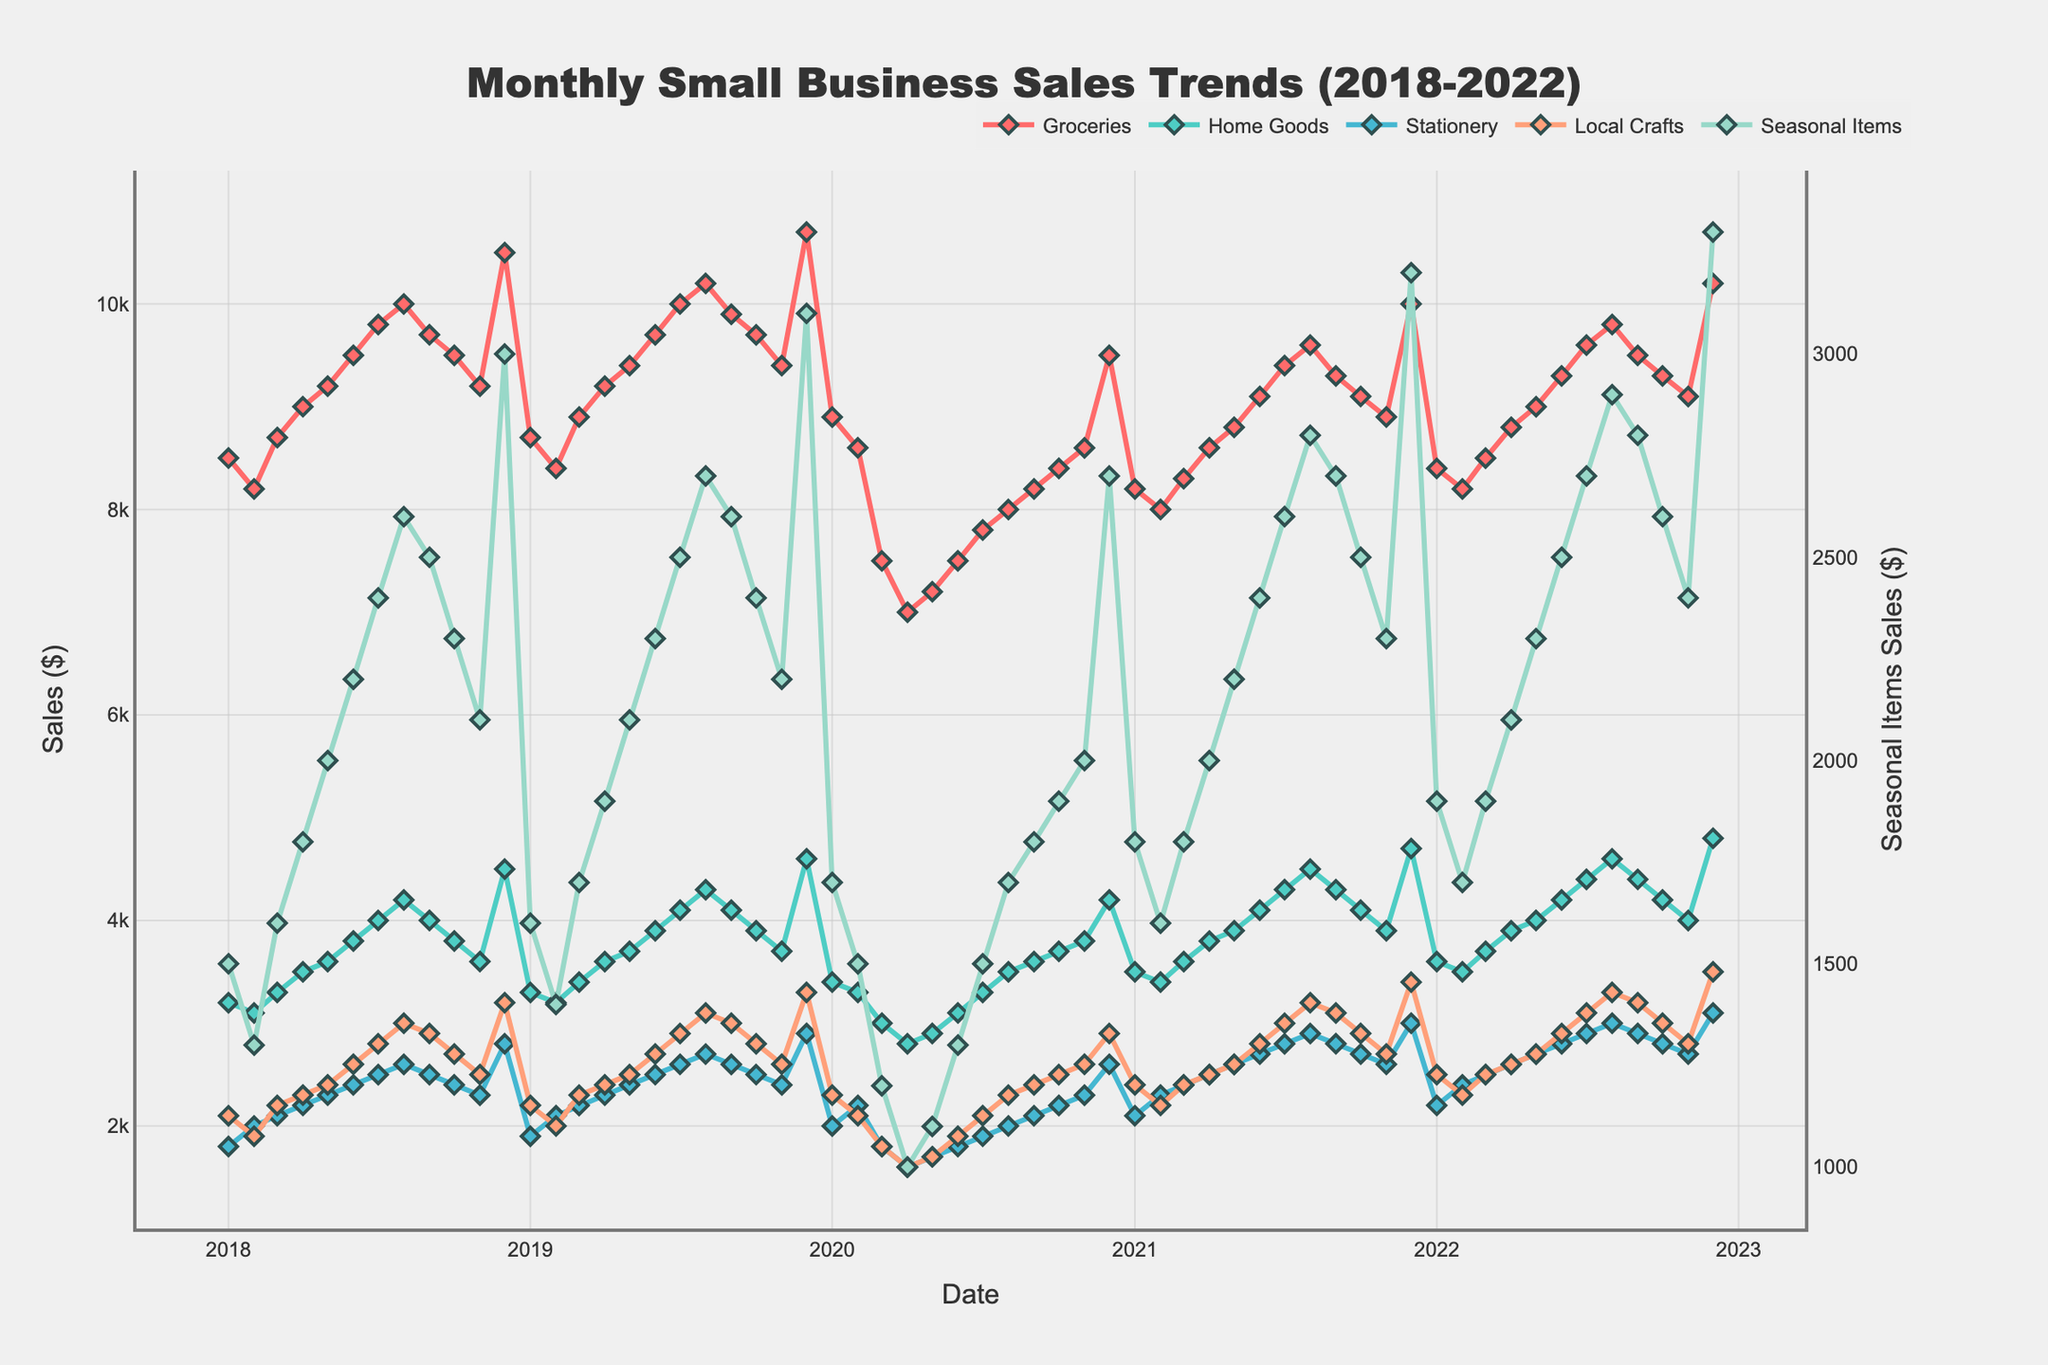Which product category had the highest sales in Dec 2022? Look at the sales value for each product category in December 2022. The highest value is 10200 for Groceries.
Answer: Groceries How did the sales of Home Goods change from Jan 2018 to Dec 2022? Compare the sales values for Home Goods in January 2018 and December 2022. The sales increased from 3200 to 4800.
Answer: Increased Which product category showed the most significant growth during 2020? Check the sales values for each category at the start (Jan 2020) and end (Dec 2020) of the year 2020. Calculate the difference for each. The most significant growth is for Groceries, from 8900 to 9500.
Answer: Groceries What was the trend for Stationery sales in 2020? Observe the line representing Stationery sales from Jan 2020 to Dec 2020. The trend shows a drop in sales until Apr 2020, followed by a gradual increase until Dec 2020.
Answer: Decrease then increase Compare the sales of Local Crafts in Mar 2020 and Mar 2021. Which month had higher sales? Compare the values of Local Crafts sales for March 2020 and March 2021. In Mar 2020, the sales were 1800, and in Mar 2021, the sales were 2400. March 2021 had higher sales.
Answer: March 2021 By how much did the sales of Seasonal Items change from Jan 2021 to Dec 2021? Calculate the difference in sales values for Seasonal Items between Jan 2021 and Dec 2021. The sales increased from 1800 to 3200, a change of 1400.
Answer: 1400 What was the average sales of Groceries in 2019? Sum all the monthly sales values for Groceries in 2019 and divide by 12. The sum is 114,000, and the average is 114,000/12 = 9500.
Answer: 9500 Which month in 2021 had the lowest Home Goods sales? Find the lowest value of Home Goods sales in 2021. The lowest value is 3400 in February.
Answer: February Compare the sales trends for Groceries and Home Goods over the 5-year period. What do you observe? Both categories show an overall increasing trend, but Groceries show a more consistent and steeper increase compared to the more fluctuating trend in Home Goods.
Answer: Consistent growth for Groceries, fluctuating for Home Goods How does the sales pattern of Seasonal Items differ from other product categories? Observe that Seasonal Items have a more fluctuating trend with significant peaks in December each year, unlike other categories which have more steady trends.
Answer: Fluctuating with December peaks 